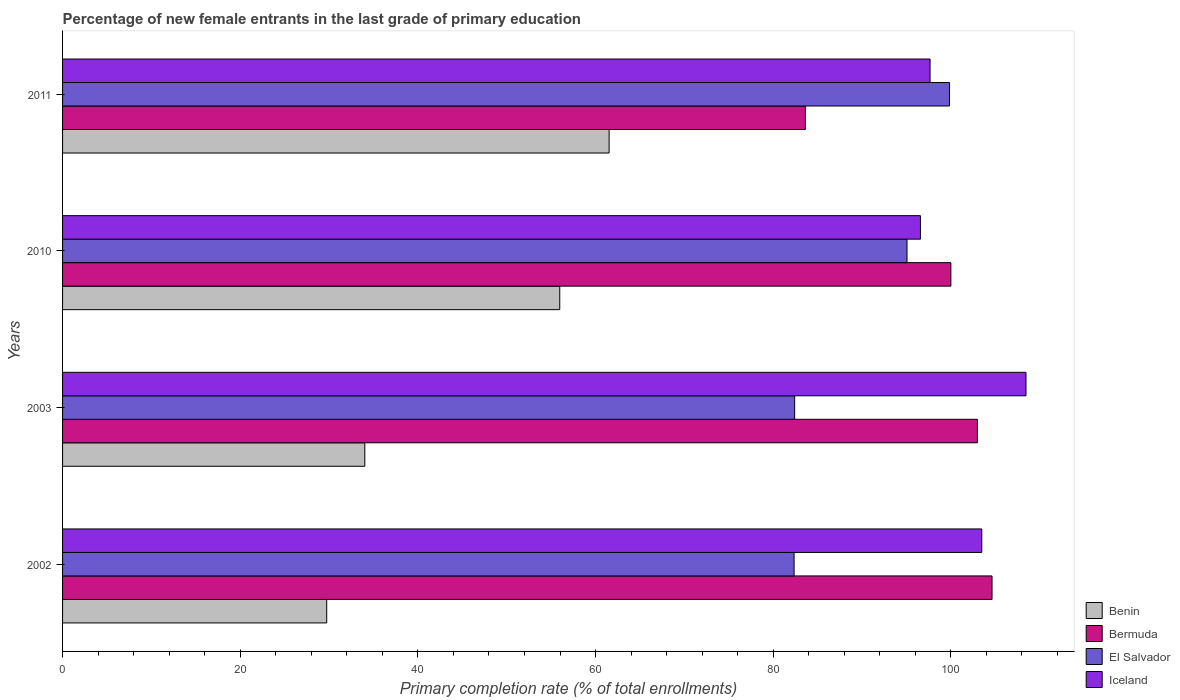How many different coloured bars are there?
Your response must be concise. 4. How many groups of bars are there?
Give a very brief answer. 4. How many bars are there on the 3rd tick from the bottom?
Provide a succinct answer. 4. What is the percentage of new female entrants in Benin in 2003?
Provide a short and direct response. 34.02. Across all years, what is the maximum percentage of new female entrants in Benin?
Provide a short and direct response. 61.53. Across all years, what is the minimum percentage of new female entrants in Iceland?
Offer a very short reply. 96.57. In which year was the percentage of new female entrants in Bermuda minimum?
Make the answer very short. 2011. What is the total percentage of new female entrants in Benin in the graph?
Offer a terse response. 181.26. What is the difference between the percentage of new female entrants in Iceland in 2010 and that in 2011?
Offer a terse response. -1.08. What is the difference between the percentage of new female entrants in Bermuda in 2003 and the percentage of new female entrants in Benin in 2002?
Keep it short and to the point. 73.25. What is the average percentage of new female entrants in Benin per year?
Ensure brevity in your answer.  45.31. In the year 2011, what is the difference between the percentage of new female entrants in Benin and percentage of new female entrants in Bermuda?
Offer a terse response. -22.1. In how many years, is the percentage of new female entrants in Benin greater than 68 %?
Provide a short and direct response. 0. What is the ratio of the percentage of new female entrants in El Salvador in 2010 to that in 2011?
Give a very brief answer. 0.95. Is the difference between the percentage of new female entrants in Benin in 2002 and 2010 greater than the difference between the percentage of new female entrants in Bermuda in 2002 and 2010?
Keep it short and to the point. No. What is the difference between the highest and the second highest percentage of new female entrants in Bermuda?
Your answer should be very brief. 1.65. What is the difference between the highest and the lowest percentage of new female entrants in Bermuda?
Give a very brief answer. 21.01. Is it the case that in every year, the sum of the percentage of new female entrants in Benin and percentage of new female entrants in El Salvador is greater than the sum of percentage of new female entrants in Bermuda and percentage of new female entrants in Iceland?
Keep it short and to the point. No. What does the 4th bar from the top in 2002 represents?
Your answer should be compact. Benin. What does the 3rd bar from the bottom in 2011 represents?
Give a very brief answer. El Salvador. How many bars are there?
Provide a short and direct response. 16. Are all the bars in the graph horizontal?
Offer a terse response. Yes. What is the difference between two consecutive major ticks on the X-axis?
Your response must be concise. 20. Are the values on the major ticks of X-axis written in scientific E-notation?
Give a very brief answer. No. Does the graph contain grids?
Provide a short and direct response. No. What is the title of the graph?
Provide a succinct answer. Percentage of new female entrants in the last grade of primary education. What is the label or title of the X-axis?
Offer a terse response. Primary completion rate (% of total enrollments). What is the Primary completion rate (% of total enrollments) of Benin in 2002?
Your answer should be compact. 29.74. What is the Primary completion rate (% of total enrollments) in Bermuda in 2002?
Your response must be concise. 104.63. What is the Primary completion rate (% of total enrollments) of El Salvador in 2002?
Your response must be concise. 82.35. What is the Primary completion rate (% of total enrollments) in Iceland in 2002?
Make the answer very short. 103.48. What is the Primary completion rate (% of total enrollments) in Benin in 2003?
Provide a short and direct response. 34.02. What is the Primary completion rate (% of total enrollments) of Bermuda in 2003?
Provide a succinct answer. 102.99. What is the Primary completion rate (% of total enrollments) in El Salvador in 2003?
Ensure brevity in your answer.  82.41. What is the Primary completion rate (% of total enrollments) in Iceland in 2003?
Provide a short and direct response. 108.46. What is the Primary completion rate (% of total enrollments) in Benin in 2010?
Keep it short and to the point. 55.97. What is the Primary completion rate (% of total enrollments) of Bermuda in 2010?
Keep it short and to the point. 100. What is the Primary completion rate (% of total enrollments) in El Salvador in 2010?
Your answer should be very brief. 95.06. What is the Primary completion rate (% of total enrollments) of Iceland in 2010?
Offer a terse response. 96.57. What is the Primary completion rate (% of total enrollments) of Benin in 2011?
Your answer should be compact. 61.53. What is the Primary completion rate (% of total enrollments) in Bermuda in 2011?
Give a very brief answer. 83.63. What is the Primary completion rate (% of total enrollments) in El Salvador in 2011?
Your answer should be very brief. 99.85. What is the Primary completion rate (% of total enrollments) of Iceland in 2011?
Make the answer very short. 97.66. Across all years, what is the maximum Primary completion rate (% of total enrollments) in Benin?
Ensure brevity in your answer.  61.53. Across all years, what is the maximum Primary completion rate (% of total enrollments) in Bermuda?
Your answer should be very brief. 104.63. Across all years, what is the maximum Primary completion rate (% of total enrollments) in El Salvador?
Your answer should be very brief. 99.85. Across all years, what is the maximum Primary completion rate (% of total enrollments) of Iceland?
Provide a short and direct response. 108.46. Across all years, what is the minimum Primary completion rate (% of total enrollments) of Benin?
Offer a terse response. 29.74. Across all years, what is the minimum Primary completion rate (% of total enrollments) of Bermuda?
Your answer should be very brief. 83.63. Across all years, what is the minimum Primary completion rate (% of total enrollments) of El Salvador?
Your answer should be compact. 82.35. Across all years, what is the minimum Primary completion rate (% of total enrollments) of Iceland?
Give a very brief answer. 96.57. What is the total Primary completion rate (% of total enrollments) of Benin in the graph?
Keep it short and to the point. 181.26. What is the total Primary completion rate (% of total enrollments) in Bermuda in the graph?
Your answer should be compact. 391.25. What is the total Primary completion rate (% of total enrollments) of El Salvador in the graph?
Make the answer very short. 359.68. What is the total Primary completion rate (% of total enrollments) of Iceland in the graph?
Give a very brief answer. 406.17. What is the difference between the Primary completion rate (% of total enrollments) in Benin in 2002 and that in 2003?
Ensure brevity in your answer.  -4.29. What is the difference between the Primary completion rate (% of total enrollments) of Bermuda in 2002 and that in 2003?
Keep it short and to the point. 1.65. What is the difference between the Primary completion rate (% of total enrollments) of El Salvador in 2002 and that in 2003?
Your response must be concise. -0.06. What is the difference between the Primary completion rate (% of total enrollments) of Iceland in 2002 and that in 2003?
Make the answer very short. -4.98. What is the difference between the Primary completion rate (% of total enrollments) of Benin in 2002 and that in 2010?
Your answer should be compact. -26.23. What is the difference between the Primary completion rate (% of total enrollments) of Bermuda in 2002 and that in 2010?
Your answer should be compact. 4.63. What is the difference between the Primary completion rate (% of total enrollments) in El Salvador in 2002 and that in 2010?
Make the answer very short. -12.71. What is the difference between the Primary completion rate (% of total enrollments) of Iceland in 2002 and that in 2010?
Keep it short and to the point. 6.9. What is the difference between the Primary completion rate (% of total enrollments) of Benin in 2002 and that in 2011?
Provide a short and direct response. -31.79. What is the difference between the Primary completion rate (% of total enrollments) in Bermuda in 2002 and that in 2011?
Your response must be concise. 21.01. What is the difference between the Primary completion rate (% of total enrollments) in El Salvador in 2002 and that in 2011?
Provide a short and direct response. -17.5. What is the difference between the Primary completion rate (% of total enrollments) in Iceland in 2002 and that in 2011?
Your answer should be very brief. 5.82. What is the difference between the Primary completion rate (% of total enrollments) in Benin in 2003 and that in 2010?
Give a very brief answer. -21.94. What is the difference between the Primary completion rate (% of total enrollments) of Bermuda in 2003 and that in 2010?
Give a very brief answer. 2.99. What is the difference between the Primary completion rate (% of total enrollments) in El Salvador in 2003 and that in 2010?
Ensure brevity in your answer.  -12.65. What is the difference between the Primary completion rate (% of total enrollments) in Iceland in 2003 and that in 2010?
Offer a very short reply. 11.88. What is the difference between the Primary completion rate (% of total enrollments) in Benin in 2003 and that in 2011?
Ensure brevity in your answer.  -27.5. What is the difference between the Primary completion rate (% of total enrollments) in Bermuda in 2003 and that in 2011?
Your answer should be very brief. 19.36. What is the difference between the Primary completion rate (% of total enrollments) in El Salvador in 2003 and that in 2011?
Offer a very short reply. -17.43. What is the difference between the Primary completion rate (% of total enrollments) in Iceland in 2003 and that in 2011?
Give a very brief answer. 10.8. What is the difference between the Primary completion rate (% of total enrollments) in Benin in 2010 and that in 2011?
Your answer should be compact. -5.56. What is the difference between the Primary completion rate (% of total enrollments) in Bermuda in 2010 and that in 2011?
Your answer should be very brief. 16.37. What is the difference between the Primary completion rate (% of total enrollments) in El Salvador in 2010 and that in 2011?
Offer a terse response. -4.79. What is the difference between the Primary completion rate (% of total enrollments) of Iceland in 2010 and that in 2011?
Give a very brief answer. -1.08. What is the difference between the Primary completion rate (% of total enrollments) in Benin in 2002 and the Primary completion rate (% of total enrollments) in Bermuda in 2003?
Offer a very short reply. -73.25. What is the difference between the Primary completion rate (% of total enrollments) in Benin in 2002 and the Primary completion rate (% of total enrollments) in El Salvador in 2003?
Keep it short and to the point. -52.68. What is the difference between the Primary completion rate (% of total enrollments) of Benin in 2002 and the Primary completion rate (% of total enrollments) of Iceland in 2003?
Provide a short and direct response. -78.72. What is the difference between the Primary completion rate (% of total enrollments) of Bermuda in 2002 and the Primary completion rate (% of total enrollments) of El Salvador in 2003?
Your answer should be compact. 22.22. What is the difference between the Primary completion rate (% of total enrollments) in Bermuda in 2002 and the Primary completion rate (% of total enrollments) in Iceland in 2003?
Offer a very short reply. -3.82. What is the difference between the Primary completion rate (% of total enrollments) in El Salvador in 2002 and the Primary completion rate (% of total enrollments) in Iceland in 2003?
Your response must be concise. -26.11. What is the difference between the Primary completion rate (% of total enrollments) in Benin in 2002 and the Primary completion rate (% of total enrollments) in Bermuda in 2010?
Provide a succinct answer. -70.26. What is the difference between the Primary completion rate (% of total enrollments) of Benin in 2002 and the Primary completion rate (% of total enrollments) of El Salvador in 2010?
Your answer should be compact. -65.33. What is the difference between the Primary completion rate (% of total enrollments) of Benin in 2002 and the Primary completion rate (% of total enrollments) of Iceland in 2010?
Give a very brief answer. -66.84. What is the difference between the Primary completion rate (% of total enrollments) of Bermuda in 2002 and the Primary completion rate (% of total enrollments) of El Salvador in 2010?
Your response must be concise. 9.57. What is the difference between the Primary completion rate (% of total enrollments) of Bermuda in 2002 and the Primary completion rate (% of total enrollments) of Iceland in 2010?
Your response must be concise. 8.06. What is the difference between the Primary completion rate (% of total enrollments) of El Salvador in 2002 and the Primary completion rate (% of total enrollments) of Iceland in 2010?
Provide a short and direct response. -14.22. What is the difference between the Primary completion rate (% of total enrollments) in Benin in 2002 and the Primary completion rate (% of total enrollments) in Bermuda in 2011?
Your answer should be very brief. -53.89. What is the difference between the Primary completion rate (% of total enrollments) in Benin in 2002 and the Primary completion rate (% of total enrollments) in El Salvador in 2011?
Your response must be concise. -70.11. What is the difference between the Primary completion rate (% of total enrollments) in Benin in 2002 and the Primary completion rate (% of total enrollments) in Iceland in 2011?
Keep it short and to the point. -67.92. What is the difference between the Primary completion rate (% of total enrollments) in Bermuda in 2002 and the Primary completion rate (% of total enrollments) in El Salvador in 2011?
Your answer should be compact. 4.79. What is the difference between the Primary completion rate (% of total enrollments) in Bermuda in 2002 and the Primary completion rate (% of total enrollments) in Iceland in 2011?
Make the answer very short. 6.98. What is the difference between the Primary completion rate (% of total enrollments) in El Salvador in 2002 and the Primary completion rate (% of total enrollments) in Iceland in 2011?
Your answer should be compact. -15.31. What is the difference between the Primary completion rate (% of total enrollments) of Benin in 2003 and the Primary completion rate (% of total enrollments) of Bermuda in 2010?
Give a very brief answer. -65.98. What is the difference between the Primary completion rate (% of total enrollments) of Benin in 2003 and the Primary completion rate (% of total enrollments) of El Salvador in 2010?
Provide a short and direct response. -61.04. What is the difference between the Primary completion rate (% of total enrollments) of Benin in 2003 and the Primary completion rate (% of total enrollments) of Iceland in 2010?
Offer a terse response. -62.55. What is the difference between the Primary completion rate (% of total enrollments) of Bermuda in 2003 and the Primary completion rate (% of total enrollments) of El Salvador in 2010?
Make the answer very short. 7.92. What is the difference between the Primary completion rate (% of total enrollments) of Bermuda in 2003 and the Primary completion rate (% of total enrollments) of Iceland in 2010?
Give a very brief answer. 6.41. What is the difference between the Primary completion rate (% of total enrollments) in El Salvador in 2003 and the Primary completion rate (% of total enrollments) in Iceland in 2010?
Offer a very short reply. -14.16. What is the difference between the Primary completion rate (% of total enrollments) in Benin in 2003 and the Primary completion rate (% of total enrollments) in Bermuda in 2011?
Keep it short and to the point. -49.6. What is the difference between the Primary completion rate (% of total enrollments) in Benin in 2003 and the Primary completion rate (% of total enrollments) in El Salvador in 2011?
Provide a short and direct response. -65.82. What is the difference between the Primary completion rate (% of total enrollments) of Benin in 2003 and the Primary completion rate (% of total enrollments) of Iceland in 2011?
Provide a succinct answer. -63.63. What is the difference between the Primary completion rate (% of total enrollments) in Bermuda in 2003 and the Primary completion rate (% of total enrollments) in El Salvador in 2011?
Offer a terse response. 3.14. What is the difference between the Primary completion rate (% of total enrollments) in Bermuda in 2003 and the Primary completion rate (% of total enrollments) in Iceland in 2011?
Make the answer very short. 5.33. What is the difference between the Primary completion rate (% of total enrollments) in El Salvador in 2003 and the Primary completion rate (% of total enrollments) in Iceland in 2011?
Give a very brief answer. -15.24. What is the difference between the Primary completion rate (% of total enrollments) of Benin in 2010 and the Primary completion rate (% of total enrollments) of Bermuda in 2011?
Make the answer very short. -27.66. What is the difference between the Primary completion rate (% of total enrollments) of Benin in 2010 and the Primary completion rate (% of total enrollments) of El Salvador in 2011?
Ensure brevity in your answer.  -43.88. What is the difference between the Primary completion rate (% of total enrollments) of Benin in 2010 and the Primary completion rate (% of total enrollments) of Iceland in 2011?
Offer a terse response. -41.69. What is the difference between the Primary completion rate (% of total enrollments) of Bermuda in 2010 and the Primary completion rate (% of total enrollments) of El Salvador in 2011?
Offer a terse response. 0.15. What is the difference between the Primary completion rate (% of total enrollments) of Bermuda in 2010 and the Primary completion rate (% of total enrollments) of Iceland in 2011?
Your answer should be compact. 2.34. What is the difference between the Primary completion rate (% of total enrollments) of El Salvador in 2010 and the Primary completion rate (% of total enrollments) of Iceland in 2011?
Your response must be concise. -2.59. What is the average Primary completion rate (% of total enrollments) in Benin per year?
Offer a very short reply. 45.31. What is the average Primary completion rate (% of total enrollments) in Bermuda per year?
Your answer should be compact. 97.81. What is the average Primary completion rate (% of total enrollments) of El Salvador per year?
Your answer should be compact. 89.92. What is the average Primary completion rate (% of total enrollments) of Iceland per year?
Keep it short and to the point. 101.54. In the year 2002, what is the difference between the Primary completion rate (% of total enrollments) of Benin and Primary completion rate (% of total enrollments) of Bermuda?
Offer a very short reply. -74.9. In the year 2002, what is the difference between the Primary completion rate (% of total enrollments) in Benin and Primary completion rate (% of total enrollments) in El Salvador?
Keep it short and to the point. -52.62. In the year 2002, what is the difference between the Primary completion rate (% of total enrollments) in Benin and Primary completion rate (% of total enrollments) in Iceland?
Give a very brief answer. -73.74. In the year 2002, what is the difference between the Primary completion rate (% of total enrollments) of Bermuda and Primary completion rate (% of total enrollments) of El Salvador?
Provide a short and direct response. 22.28. In the year 2002, what is the difference between the Primary completion rate (% of total enrollments) of Bermuda and Primary completion rate (% of total enrollments) of Iceland?
Give a very brief answer. 1.16. In the year 2002, what is the difference between the Primary completion rate (% of total enrollments) of El Salvador and Primary completion rate (% of total enrollments) of Iceland?
Offer a very short reply. -21.13. In the year 2003, what is the difference between the Primary completion rate (% of total enrollments) in Benin and Primary completion rate (% of total enrollments) in Bermuda?
Provide a short and direct response. -68.96. In the year 2003, what is the difference between the Primary completion rate (% of total enrollments) of Benin and Primary completion rate (% of total enrollments) of El Salvador?
Give a very brief answer. -48.39. In the year 2003, what is the difference between the Primary completion rate (% of total enrollments) of Benin and Primary completion rate (% of total enrollments) of Iceland?
Keep it short and to the point. -74.43. In the year 2003, what is the difference between the Primary completion rate (% of total enrollments) of Bermuda and Primary completion rate (% of total enrollments) of El Salvador?
Your answer should be compact. 20.57. In the year 2003, what is the difference between the Primary completion rate (% of total enrollments) in Bermuda and Primary completion rate (% of total enrollments) in Iceland?
Your response must be concise. -5.47. In the year 2003, what is the difference between the Primary completion rate (% of total enrollments) of El Salvador and Primary completion rate (% of total enrollments) of Iceland?
Provide a succinct answer. -26.04. In the year 2010, what is the difference between the Primary completion rate (% of total enrollments) of Benin and Primary completion rate (% of total enrollments) of Bermuda?
Your answer should be very brief. -44.03. In the year 2010, what is the difference between the Primary completion rate (% of total enrollments) in Benin and Primary completion rate (% of total enrollments) in El Salvador?
Offer a very short reply. -39.09. In the year 2010, what is the difference between the Primary completion rate (% of total enrollments) in Benin and Primary completion rate (% of total enrollments) in Iceland?
Provide a short and direct response. -40.6. In the year 2010, what is the difference between the Primary completion rate (% of total enrollments) in Bermuda and Primary completion rate (% of total enrollments) in El Salvador?
Offer a terse response. 4.94. In the year 2010, what is the difference between the Primary completion rate (% of total enrollments) of Bermuda and Primary completion rate (% of total enrollments) of Iceland?
Offer a very short reply. 3.43. In the year 2010, what is the difference between the Primary completion rate (% of total enrollments) of El Salvador and Primary completion rate (% of total enrollments) of Iceland?
Keep it short and to the point. -1.51. In the year 2011, what is the difference between the Primary completion rate (% of total enrollments) of Benin and Primary completion rate (% of total enrollments) of Bermuda?
Provide a succinct answer. -22.1. In the year 2011, what is the difference between the Primary completion rate (% of total enrollments) of Benin and Primary completion rate (% of total enrollments) of El Salvador?
Offer a very short reply. -38.32. In the year 2011, what is the difference between the Primary completion rate (% of total enrollments) of Benin and Primary completion rate (% of total enrollments) of Iceland?
Offer a terse response. -36.13. In the year 2011, what is the difference between the Primary completion rate (% of total enrollments) in Bermuda and Primary completion rate (% of total enrollments) in El Salvador?
Give a very brief answer. -16.22. In the year 2011, what is the difference between the Primary completion rate (% of total enrollments) of Bermuda and Primary completion rate (% of total enrollments) of Iceland?
Offer a terse response. -14.03. In the year 2011, what is the difference between the Primary completion rate (% of total enrollments) of El Salvador and Primary completion rate (% of total enrollments) of Iceland?
Offer a very short reply. 2.19. What is the ratio of the Primary completion rate (% of total enrollments) in Benin in 2002 to that in 2003?
Your response must be concise. 0.87. What is the ratio of the Primary completion rate (% of total enrollments) of Bermuda in 2002 to that in 2003?
Your response must be concise. 1.02. What is the ratio of the Primary completion rate (% of total enrollments) in El Salvador in 2002 to that in 2003?
Offer a very short reply. 1. What is the ratio of the Primary completion rate (% of total enrollments) in Iceland in 2002 to that in 2003?
Make the answer very short. 0.95. What is the ratio of the Primary completion rate (% of total enrollments) of Benin in 2002 to that in 2010?
Provide a succinct answer. 0.53. What is the ratio of the Primary completion rate (% of total enrollments) in Bermuda in 2002 to that in 2010?
Your response must be concise. 1.05. What is the ratio of the Primary completion rate (% of total enrollments) in El Salvador in 2002 to that in 2010?
Keep it short and to the point. 0.87. What is the ratio of the Primary completion rate (% of total enrollments) in Iceland in 2002 to that in 2010?
Offer a very short reply. 1.07. What is the ratio of the Primary completion rate (% of total enrollments) of Benin in 2002 to that in 2011?
Your answer should be compact. 0.48. What is the ratio of the Primary completion rate (% of total enrollments) of Bermuda in 2002 to that in 2011?
Ensure brevity in your answer.  1.25. What is the ratio of the Primary completion rate (% of total enrollments) of El Salvador in 2002 to that in 2011?
Offer a terse response. 0.82. What is the ratio of the Primary completion rate (% of total enrollments) of Iceland in 2002 to that in 2011?
Your response must be concise. 1.06. What is the ratio of the Primary completion rate (% of total enrollments) of Benin in 2003 to that in 2010?
Your answer should be very brief. 0.61. What is the ratio of the Primary completion rate (% of total enrollments) of Bermuda in 2003 to that in 2010?
Give a very brief answer. 1.03. What is the ratio of the Primary completion rate (% of total enrollments) in El Salvador in 2003 to that in 2010?
Give a very brief answer. 0.87. What is the ratio of the Primary completion rate (% of total enrollments) in Iceland in 2003 to that in 2010?
Ensure brevity in your answer.  1.12. What is the ratio of the Primary completion rate (% of total enrollments) of Benin in 2003 to that in 2011?
Your response must be concise. 0.55. What is the ratio of the Primary completion rate (% of total enrollments) of Bermuda in 2003 to that in 2011?
Keep it short and to the point. 1.23. What is the ratio of the Primary completion rate (% of total enrollments) in El Salvador in 2003 to that in 2011?
Offer a terse response. 0.83. What is the ratio of the Primary completion rate (% of total enrollments) in Iceland in 2003 to that in 2011?
Your response must be concise. 1.11. What is the ratio of the Primary completion rate (% of total enrollments) of Benin in 2010 to that in 2011?
Make the answer very short. 0.91. What is the ratio of the Primary completion rate (% of total enrollments) of Bermuda in 2010 to that in 2011?
Offer a very short reply. 1.2. What is the ratio of the Primary completion rate (% of total enrollments) in El Salvador in 2010 to that in 2011?
Give a very brief answer. 0.95. What is the ratio of the Primary completion rate (% of total enrollments) of Iceland in 2010 to that in 2011?
Give a very brief answer. 0.99. What is the difference between the highest and the second highest Primary completion rate (% of total enrollments) in Benin?
Offer a terse response. 5.56. What is the difference between the highest and the second highest Primary completion rate (% of total enrollments) of Bermuda?
Provide a short and direct response. 1.65. What is the difference between the highest and the second highest Primary completion rate (% of total enrollments) of El Salvador?
Your response must be concise. 4.79. What is the difference between the highest and the second highest Primary completion rate (% of total enrollments) in Iceland?
Your response must be concise. 4.98. What is the difference between the highest and the lowest Primary completion rate (% of total enrollments) in Benin?
Give a very brief answer. 31.79. What is the difference between the highest and the lowest Primary completion rate (% of total enrollments) of Bermuda?
Provide a short and direct response. 21.01. What is the difference between the highest and the lowest Primary completion rate (% of total enrollments) in El Salvador?
Keep it short and to the point. 17.5. What is the difference between the highest and the lowest Primary completion rate (% of total enrollments) in Iceland?
Ensure brevity in your answer.  11.88. 